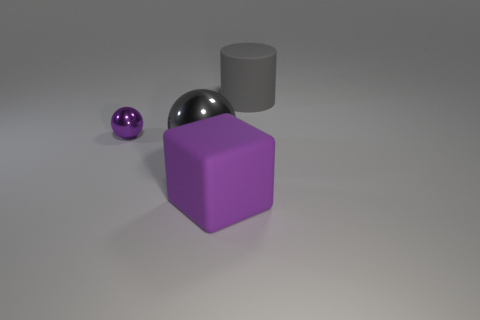What shapes are visible in the image, and can you describe their arrangement? In the image, there are three distinct shapes: a small purple sphere, a larger metallic sphere, and a purple cube. They are loosely arranged with the small sphere slightly in front of the cube, and the larger sphere off to the side. 